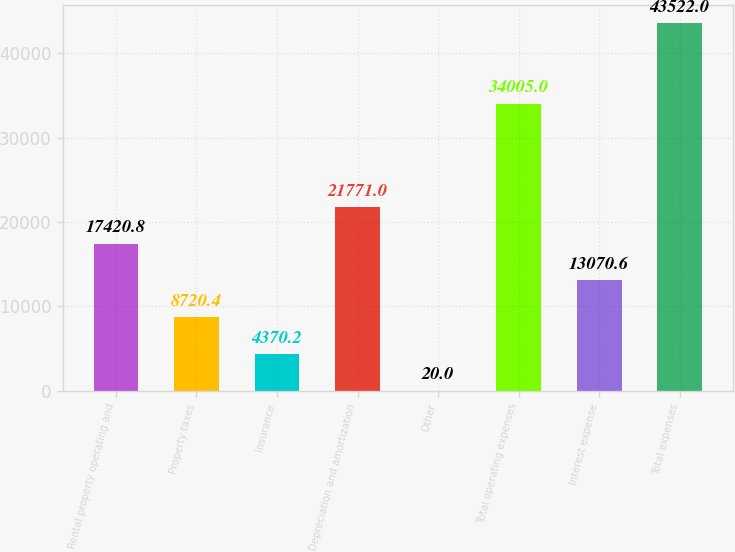<chart> <loc_0><loc_0><loc_500><loc_500><bar_chart><fcel>Rental property operating and<fcel>Property taxes<fcel>Insurance<fcel>Depreciation and amortization<fcel>Other<fcel>Total operating expenses<fcel>Interest expense<fcel>Total expenses<nl><fcel>17420.8<fcel>8720.4<fcel>4370.2<fcel>21771<fcel>20<fcel>34005<fcel>13070.6<fcel>43522<nl></chart> 